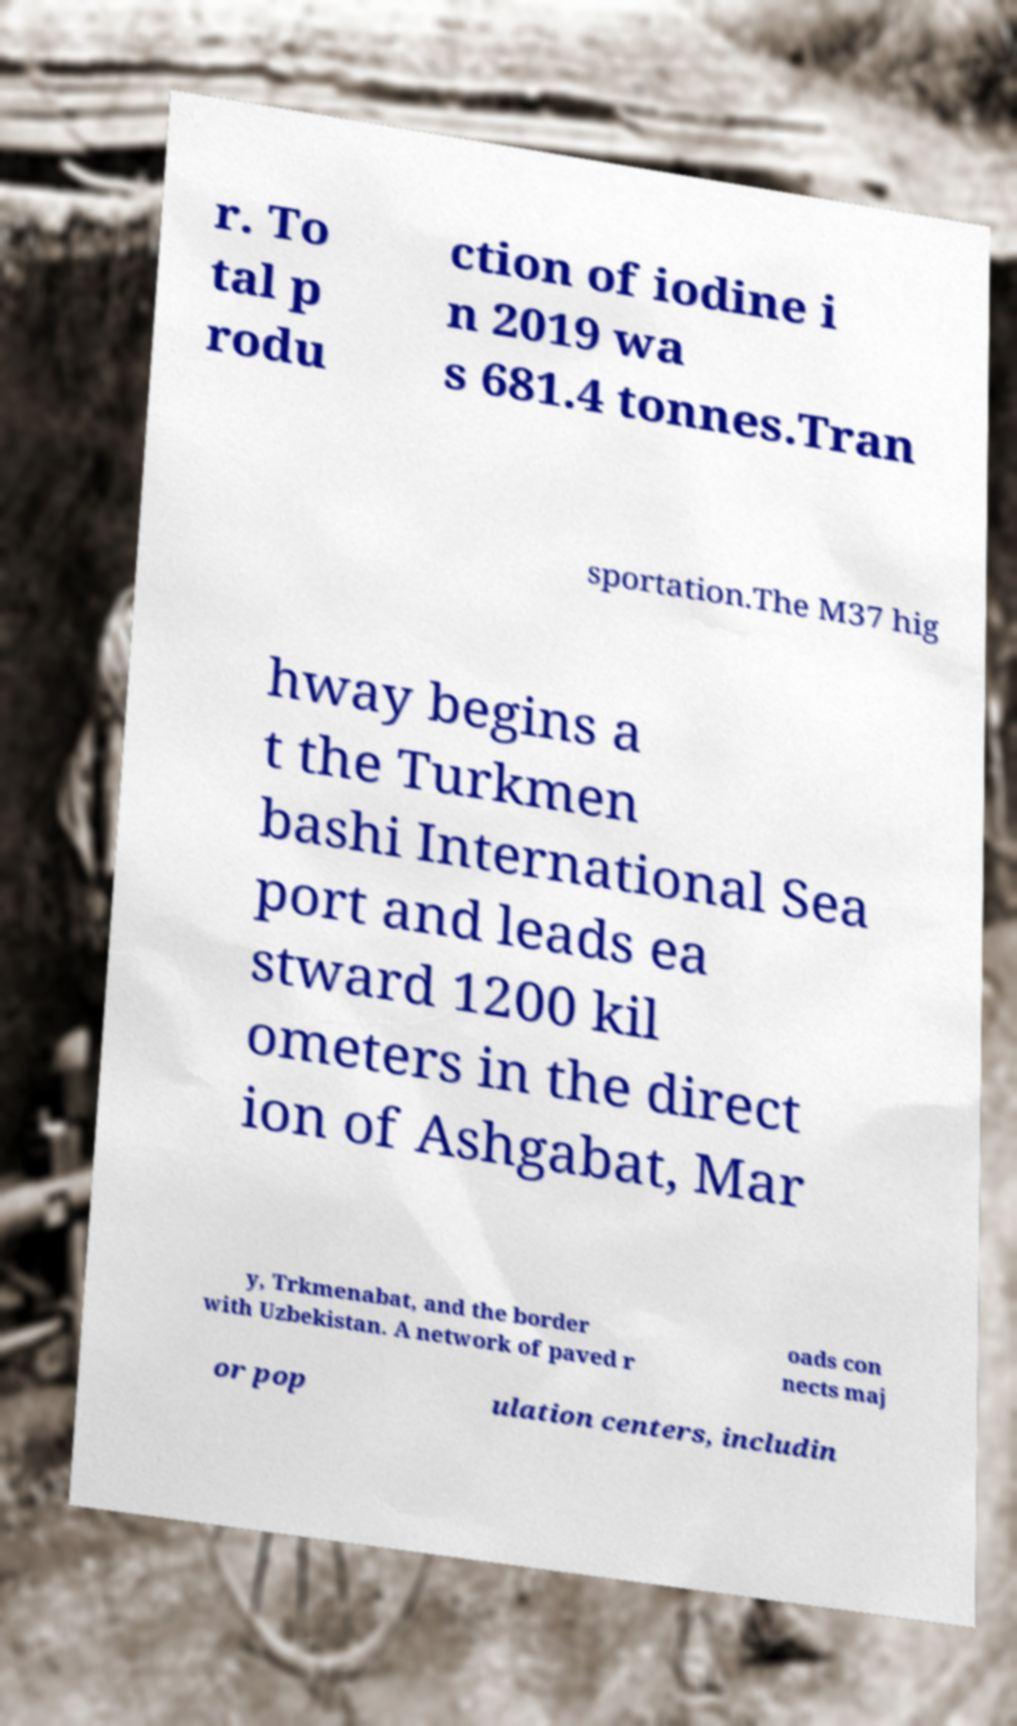For documentation purposes, I need the text within this image transcribed. Could you provide that? r. To tal p rodu ction of iodine i n 2019 wa s 681.4 tonnes.Tran sportation.The M37 hig hway begins a t the Turkmen bashi International Sea port and leads ea stward 1200 kil ometers in the direct ion of Ashgabat, Mar y, Trkmenabat, and the border with Uzbekistan. A network of paved r oads con nects maj or pop ulation centers, includin 